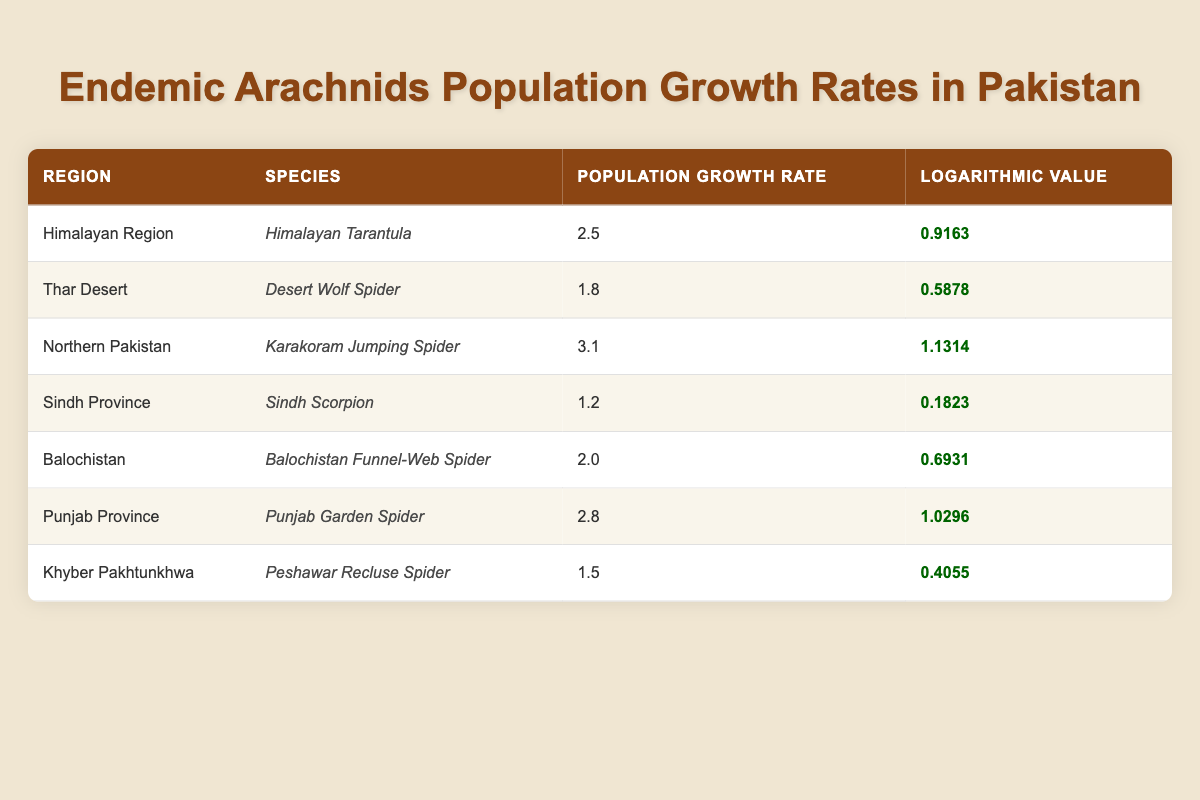What is the population growth rate of the Himalayan Tarantula? The table shows that the population growth rate for the Himalayan Tarantula under the Himalayan Region is 2.5.
Answer: 2.5 Which arachnid has the highest population growth rate? By examining the values in the Population Growth Rate column, the highest value is 3.1 for the Karakoram Jumping Spider in Northern Pakistan.
Answer: 3.1 Is the population growth rate of the Sindh Scorpion higher than that of the Peshawar Recluse Spider? The Sindh Scorpion has a population growth rate of 1.2, while the Peshawar Recluse Spider has a rate of 1.5. Since 1.2 is less than 1.5, the statement is false.
Answer: No What is the logarithmic value of the population growth rate for the Balochistan Funnel-Web Spider? The table clearly indicates that the logarithmic value corresponding to the population growth rate of 2.0 for the Balochistan Funnel-Web Spider is 0.6931.
Answer: 0.6931 Calculate the average population growth rate of arachnids in the Himalayan Region and Punjab Province. The growth rates for the Himalayan Tarantula (2.5) and Punjab Garden Spider (2.8) are added together: 2.5 + 2.8 = 5.3. Then divide by the number of species (2): 5.3 / 2 = 2.65.
Answer: 2.65 Is the population growth rate of the Desert Wolf Spider in the Thar Desert greater than 2.0? The growth rate for the Desert Wolf Spider is 1.8, which is less than 2.0. Thus, the answer to the question is false.
Answer: No What are the regions represented in the table with their corresponding arachnid species? The table lists multiple regions: Himalayan Region with Himalayan Tarantula, Thar Desert with Desert Wolf Spider, Northern Pakistan with Karakoram Jumping Spider, Sindh Province with Sindh Scorpion, Balochistan with Balochistan Funnel-Web Spider, Punjab Province with Punjab Garden Spider, and Khyber Pakhtunkhwa with Peshawar Recluse Spider.
Answer: Multiple regions are listed Find the difference in population growth rates between the Northern Pakistan and Sindh Province arachnids. The population growth rate for the Northern Pakistan arachnid (Karakoram Jumping Spider) is 3.1, and for the Sindh Province (Sindh Scorpion) it is 1.2. The difference is calculated as 3.1 - 1.2 = 1.9.
Answer: 1.9 What is the total population growth rate for Balochistan and Punjab Province combined? The growth rate for the Balochistan Funnel-Web Spider is 2.0, and for the Punjab Garden Spider, it is 2.8. The total is calculated as 2.0 + 2.8 = 4.8.
Answer: 4.8 